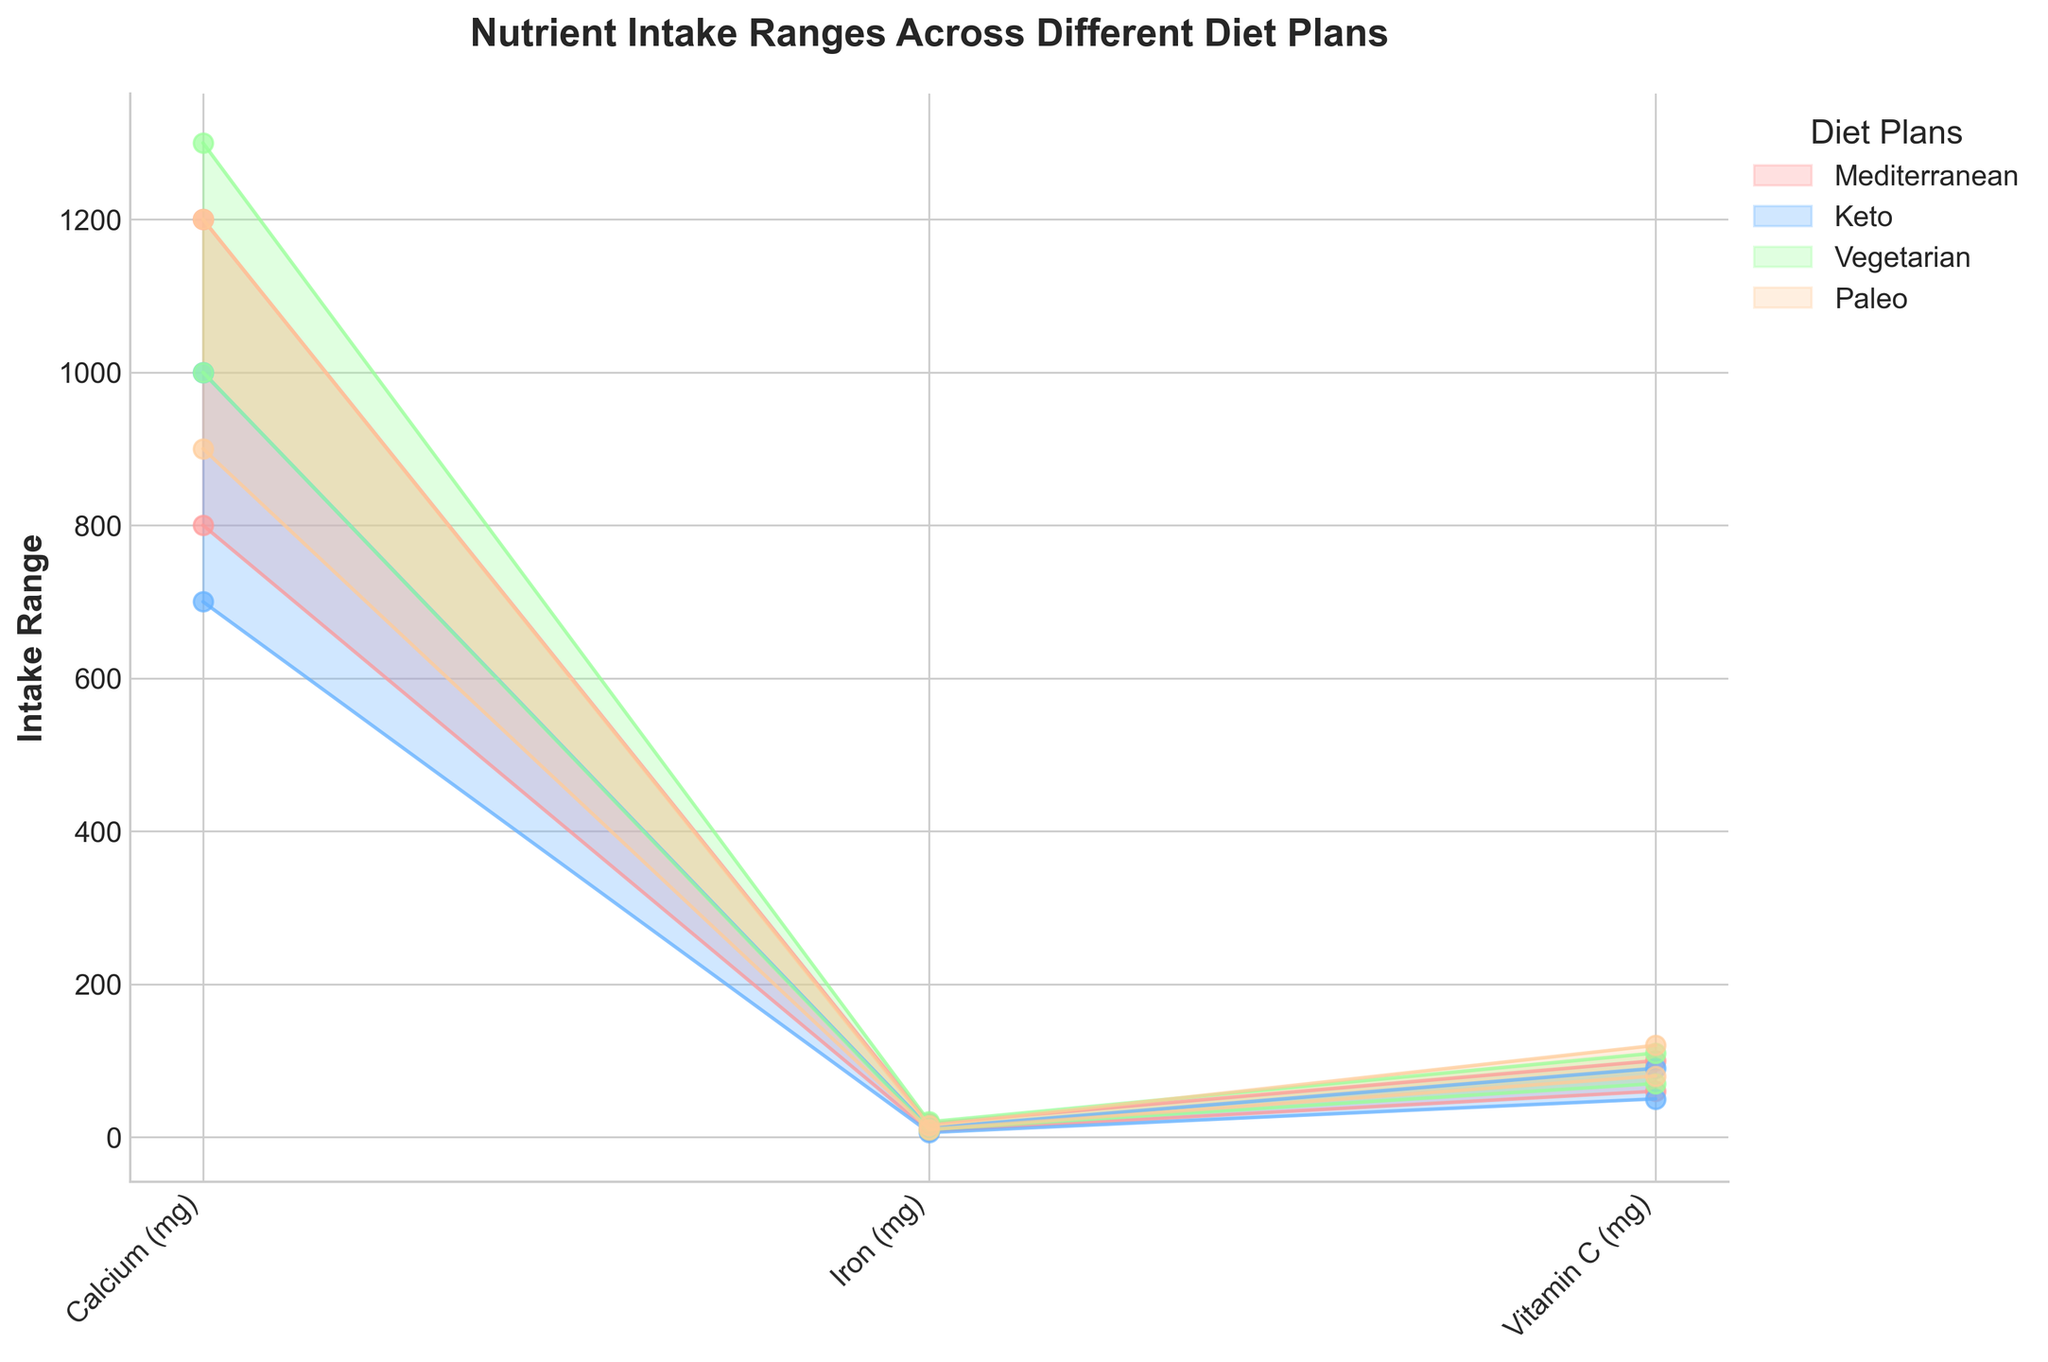What is the title of the chart? The title is shown at the top of the chart in bold text. It reads, "Nutrient Intake Ranges Across Different Diet Plans".
Answer: Nutrient Intake Ranges Across Different Diet Plans Which nutrient has the highest upper range in the Vegetarian diet plan? The Vegetarian diet plan is marked with one of the colors in the legend, and we need to look for the nutrient with the highest upper boundary. Vitamin C has the upper range of 110 mg.
Answer: Vitamin C For the Paleo diet plan, compare the calcium upper range and the iron lower range. Which one is higher? Locate the Paleo diet plan and identify the upper range for Calcium and the lower range for Iron. The upper range for Calcium is 1200 mg, and the lower range for Iron is 10 mg. Calcium's upper range is higher.
Answer: Calcium upper range What are the lower and upper ranges of Vitamin C intake in the Keto diet plan? For the Keto diet plan, find the range values for Vitamin C. The Keto diet has a lower range of 50 mg and an upper range of 90 mg for Vitamin C.
Answer: 50 mg to 90 mg Which diet plan has the highest minimum intake of Calcium? Compare the lower ranges of Calcium across all diet plans. The Vegetarian diet plan has the highest lower range for Calcium at 1000 mg.
Answer: Vegetarian How does the lower range of Iron in the Mediterranean diet compare to the upper range of Iron in the Keto diet? Look at the lower range of Iron in the Mediterranean diet (8 mg) and the upper range of Iron in the Keto diet (12 mg). The upper range of Iron in the Keto diet is higher.
Answer: Keto diet What is the range of Iron intake for the Vegetarian diet plan? Examine the lower and upper values for Iron in the Vegetarian diet plan. The range is from 10 mg to 20 mg.
Answer: 10 mg to 20 mg In which diet plan do the upper ranges for all nutrients exceed 100 mg? Review each diet plan and find one where all nutrient upper ranges are above 100 mg. The Paleo diet has upper ranges of 1200 mg for Calcium, 15 mg for Iron, and 120 mg for Vitamin C. Only Vitamin C exceeds 100 mg in Paleo plan. None fully meet the condition for all upper ranges to exceed 100 mg.
Answer: None 